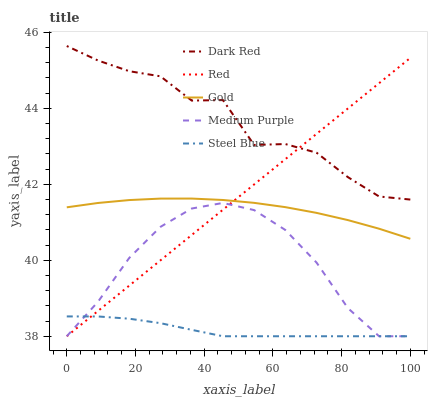Does Steel Blue have the minimum area under the curve?
Answer yes or no. Yes. Does Dark Red have the maximum area under the curve?
Answer yes or no. Yes. Does Gold have the minimum area under the curve?
Answer yes or no. No. Does Gold have the maximum area under the curve?
Answer yes or no. No. Is Red the smoothest?
Answer yes or no. Yes. Is Dark Red the roughest?
Answer yes or no. Yes. Is Gold the smoothest?
Answer yes or no. No. Is Gold the roughest?
Answer yes or no. No. Does Medium Purple have the lowest value?
Answer yes or no. Yes. Does Gold have the lowest value?
Answer yes or no. No. Does Dark Red have the highest value?
Answer yes or no. Yes. Does Gold have the highest value?
Answer yes or no. No. Is Medium Purple less than Dark Red?
Answer yes or no. Yes. Is Dark Red greater than Gold?
Answer yes or no. Yes. Does Red intersect Steel Blue?
Answer yes or no. Yes. Is Red less than Steel Blue?
Answer yes or no. No. Is Red greater than Steel Blue?
Answer yes or no. No. Does Medium Purple intersect Dark Red?
Answer yes or no. No. 